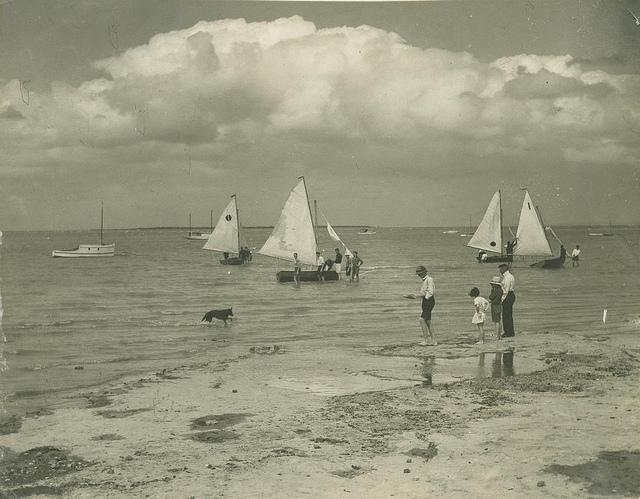What type of vehicles are in the water? sailboat 